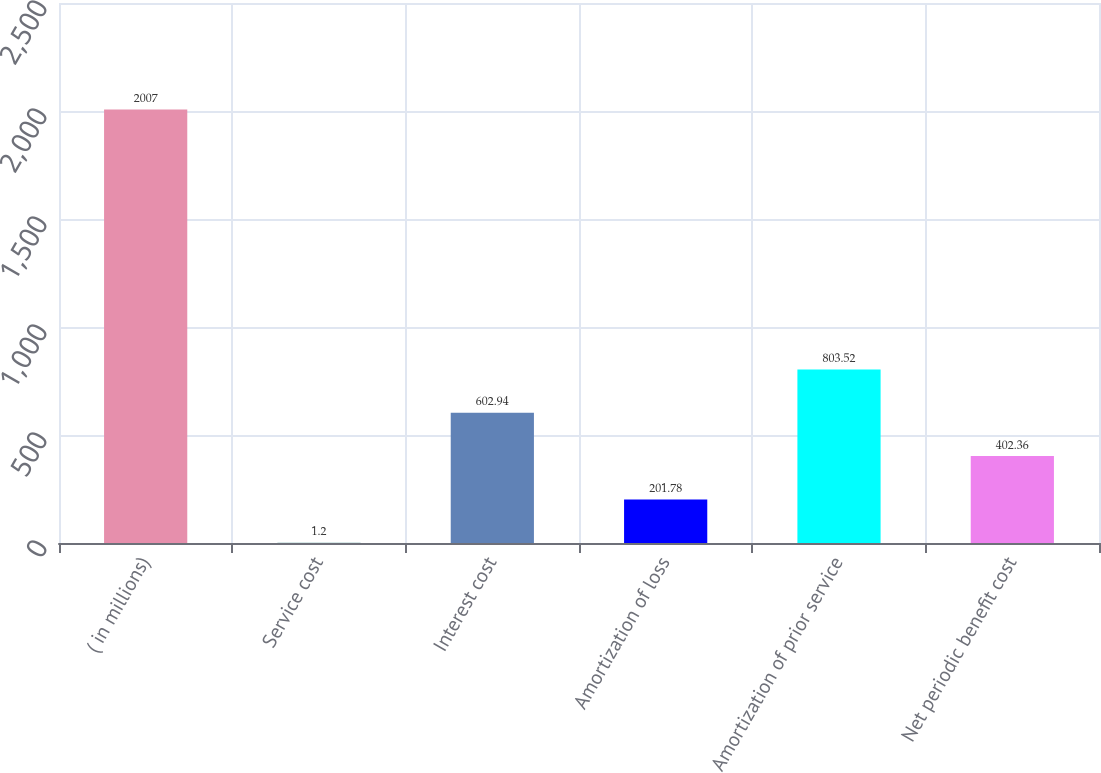Convert chart to OTSL. <chart><loc_0><loc_0><loc_500><loc_500><bar_chart><fcel>( in millions)<fcel>Service cost<fcel>Interest cost<fcel>Amortization of loss<fcel>Amortization of prior service<fcel>Net periodic benefit cost<nl><fcel>2007<fcel>1.2<fcel>602.94<fcel>201.78<fcel>803.52<fcel>402.36<nl></chart> 